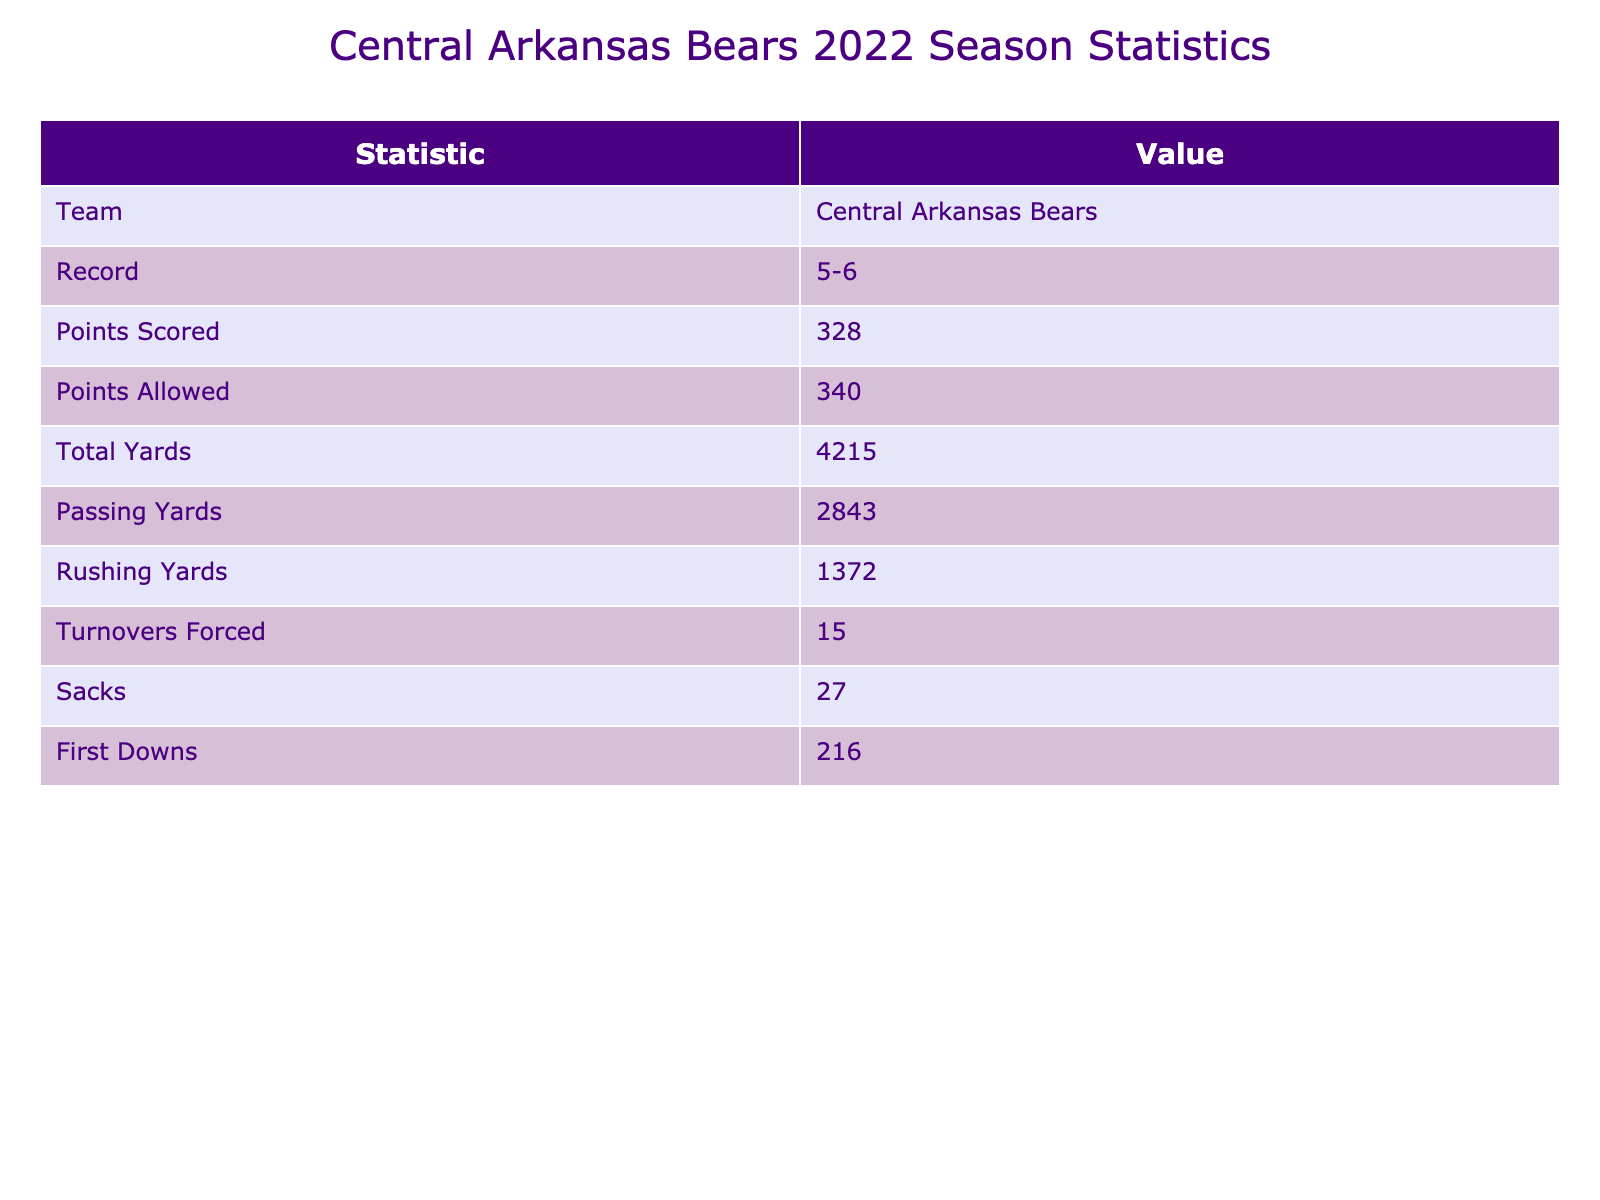What's the record of the Central Arkansas Bears for the 2022 season? The table shows the record for the Central Arkansas Bears is listed as 5-6.
Answer: 5-6 How many points did the Central Arkansas Bears score in the 2022 season? The table indicates that the Central Arkansas Bears scored a total of 328 points in the season.
Answer: 328 What is the total yardage gained by the Central Arkansas Bears in the 2022 season? The statistics show that the total yards gained by the Bears is 4215.
Answer: 4215 Did the Central Arkansas Bears allow more points than they scored in the 2022 season? To determine this, compare the points scored (328) with the points allowed (340). Since 340 is greater than 328, they allowed more points than they scored.
Answer: Yes How many turnovers did the Central Arkansas Bears force during the season? The table indicates that they forced 15 turnovers throughout the season.
Answer: 15 What is the difference between points scored and points allowed by the Central Arkansas Bears? The difference can be calculated by subtracting points allowed (340) from points scored (328), which gives 328 - 340 = -12.
Answer: -12 What proportion of total yards gained was from passing yards? The proportion is calculated by dividing the passing yards (2843) by total yards (4215), which results in 2843 / 4215 ≈ 0.674, or 67.4%.
Answer: 67.4% What is the total number of first downs the Central Arkansas Bears achieved? The table shows that the Bears achieved a total of 216 first downs during the season.
Answer: 216 If you add the sacks and turnovers forced, what is the total? To find this total, add the number of sacks (27) to the turnovers forced (15), resulting in 27 + 15 = 42.
Answer: 42 Which statistic indicates how well the Bears performed defensively and how is it relevant to their record? The points allowed statistic (340) indicates defensive performance, relating to their record since a higher number could suggest a weaker defense and therefore contribute to their below .500 record.
Answer: Points allowed indicates defensive performance 